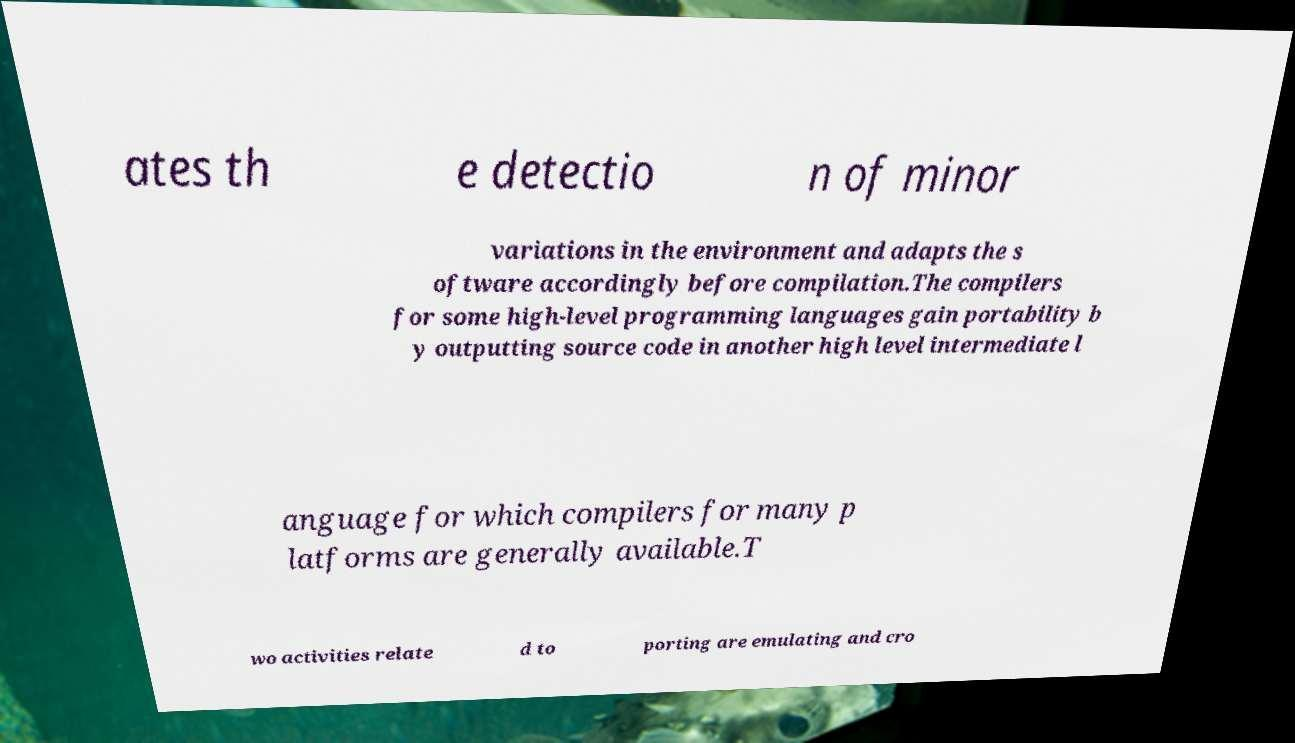There's text embedded in this image that I need extracted. Can you transcribe it verbatim? ates th e detectio n of minor variations in the environment and adapts the s oftware accordingly before compilation.The compilers for some high-level programming languages gain portability b y outputting source code in another high level intermediate l anguage for which compilers for many p latforms are generally available.T wo activities relate d to porting are emulating and cro 